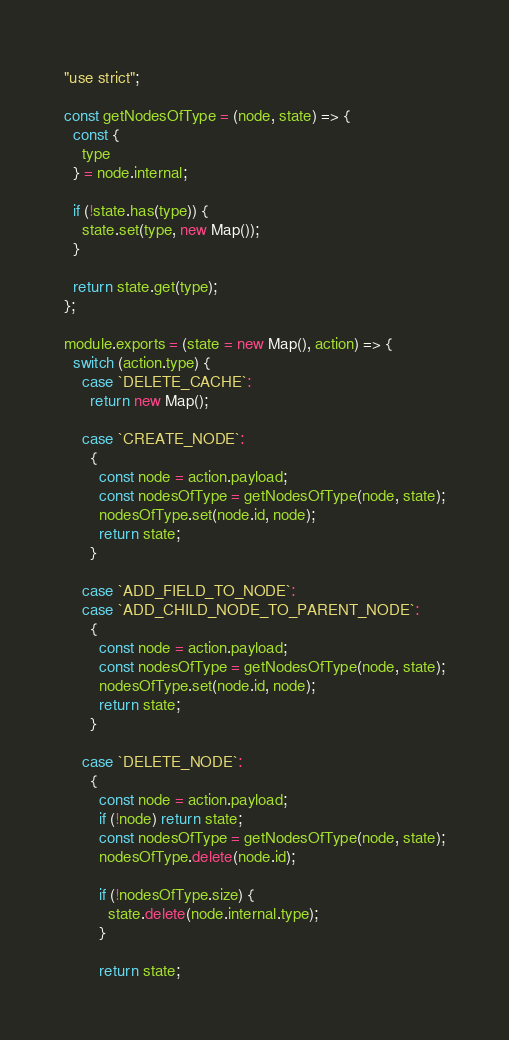Convert code to text. <code><loc_0><loc_0><loc_500><loc_500><_JavaScript_>"use strict";

const getNodesOfType = (node, state) => {
  const {
    type
  } = node.internal;

  if (!state.has(type)) {
    state.set(type, new Map());
  }

  return state.get(type);
};

module.exports = (state = new Map(), action) => {
  switch (action.type) {
    case `DELETE_CACHE`:
      return new Map();

    case `CREATE_NODE`:
      {
        const node = action.payload;
        const nodesOfType = getNodesOfType(node, state);
        nodesOfType.set(node.id, node);
        return state;
      }

    case `ADD_FIELD_TO_NODE`:
    case `ADD_CHILD_NODE_TO_PARENT_NODE`:
      {
        const node = action.payload;
        const nodesOfType = getNodesOfType(node, state);
        nodesOfType.set(node.id, node);
        return state;
      }

    case `DELETE_NODE`:
      {
        const node = action.payload;
        if (!node) return state;
        const nodesOfType = getNodesOfType(node, state);
        nodesOfType.delete(node.id);

        if (!nodesOfType.size) {
          state.delete(node.internal.type);
        }

        return state;</code> 